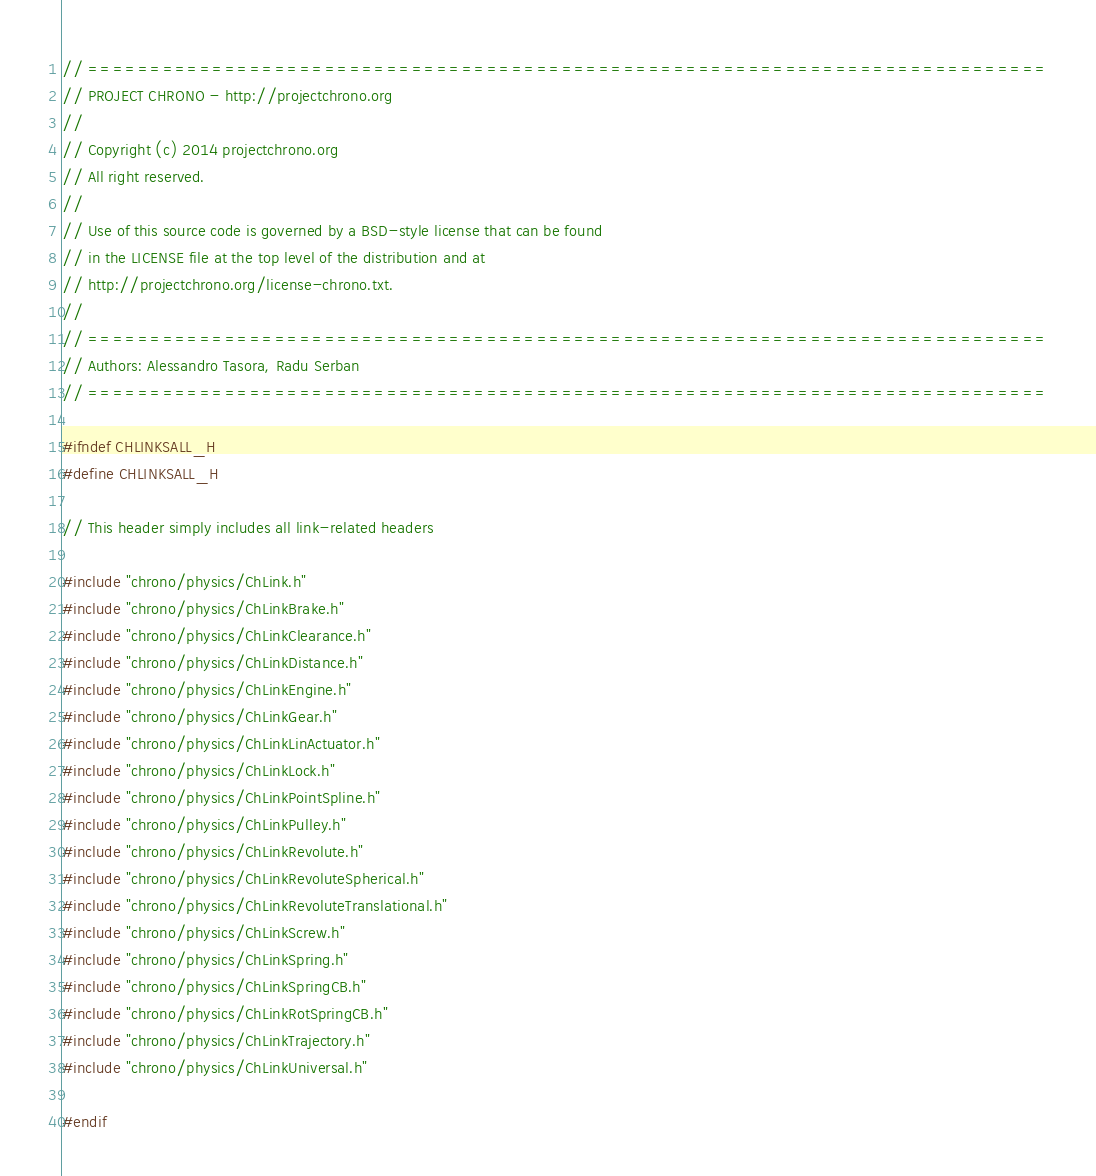<code> <loc_0><loc_0><loc_500><loc_500><_C_>// =============================================================================
// PROJECT CHRONO - http://projectchrono.org
//
// Copyright (c) 2014 projectchrono.org
// All right reserved.
//
// Use of this source code is governed by a BSD-style license that can be found
// in the LICENSE file at the top level of the distribution and at
// http://projectchrono.org/license-chrono.txt.
//
// =============================================================================
// Authors: Alessandro Tasora, Radu Serban
// =============================================================================

#ifndef CHLINKSALL_H
#define CHLINKSALL_H

// This header simply includes all link-related headers

#include "chrono/physics/ChLink.h"
#include "chrono/physics/ChLinkBrake.h"
#include "chrono/physics/ChLinkClearance.h"
#include "chrono/physics/ChLinkDistance.h"
#include "chrono/physics/ChLinkEngine.h"
#include "chrono/physics/ChLinkGear.h"
#include "chrono/physics/ChLinkLinActuator.h"
#include "chrono/physics/ChLinkLock.h"
#include "chrono/physics/ChLinkPointSpline.h"
#include "chrono/physics/ChLinkPulley.h"
#include "chrono/physics/ChLinkRevolute.h"
#include "chrono/physics/ChLinkRevoluteSpherical.h"
#include "chrono/physics/ChLinkRevoluteTranslational.h"
#include "chrono/physics/ChLinkScrew.h"
#include "chrono/physics/ChLinkSpring.h"
#include "chrono/physics/ChLinkSpringCB.h"
#include "chrono/physics/ChLinkRotSpringCB.h"
#include "chrono/physics/ChLinkTrajectory.h"
#include "chrono/physics/ChLinkUniversal.h"

#endif
</code> 